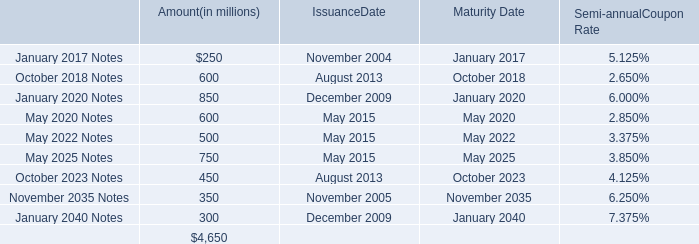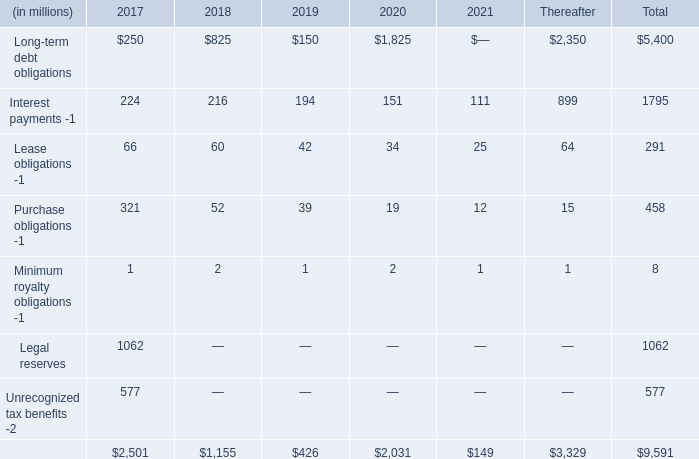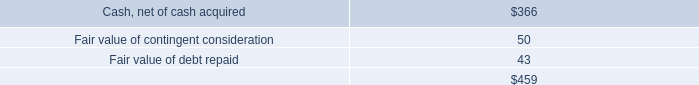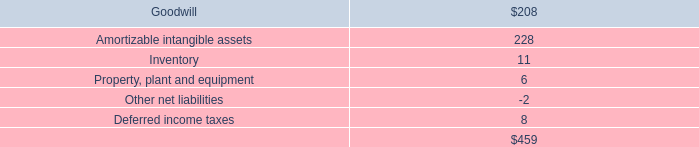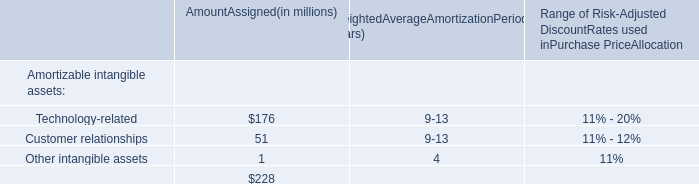What is the sum of Long-term debt obligations in the range of 200 and 260 in 2017? (in millions) 
Answer: 250. 